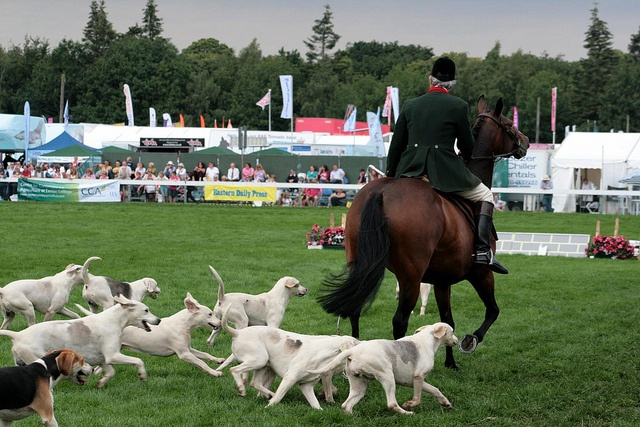Describe the objects in this image and their specific colors. I can see horse in darkgray, black, maroon, and gray tones, people in darkgray, black, gray, darkgreen, and lightgray tones, people in darkgray, gray, lightgray, and black tones, dog in darkgray, lightgray, and gray tones, and dog in darkgray, lightgray, and gray tones in this image. 